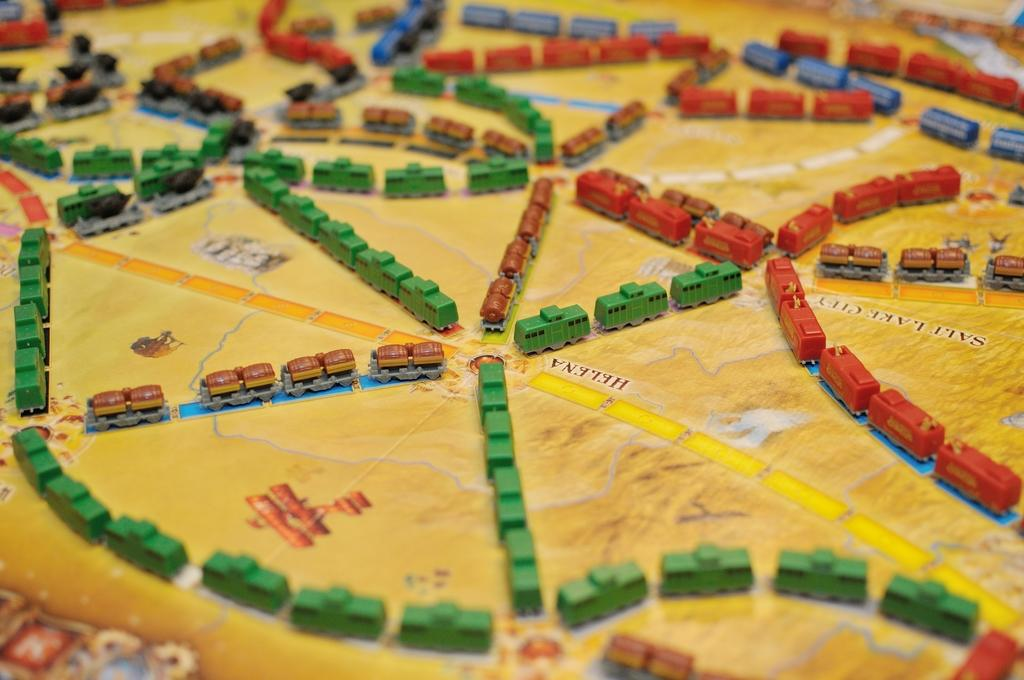What type of objects are present in the image? There are toy vehicles in the image. Where are the toy vehicles located? The toy vehicles are on a surface. Is there a paper volcano in the image? No, there is no paper volcano present in the image. 